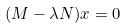<formula> <loc_0><loc_0><loc_500><loc_500>( M - \lambda N ) x = 0</formula> 